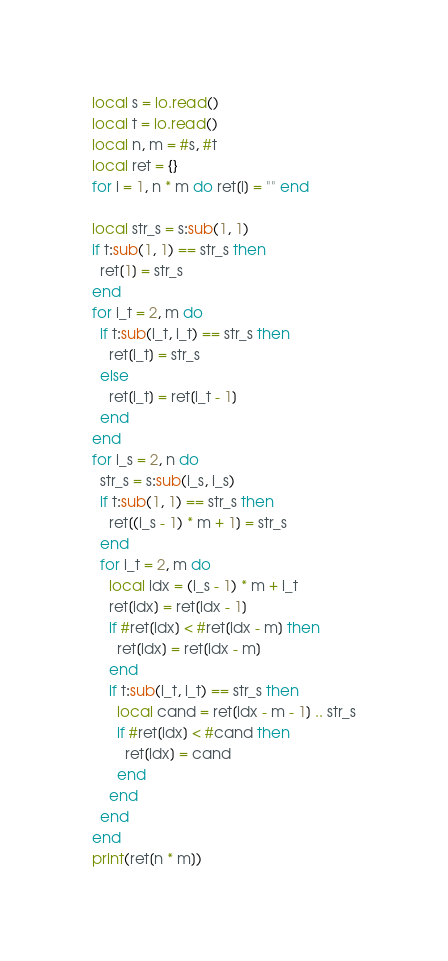Convert code to text. <code><loc_0><loc_0><loc_500><loc_500><_Lua_>local s = io.read()
local t = io.read()
local n, m = #s, #t
local ret = {}
for i = 1, n * m do ret[i] = "" end

local str_s = s:sub(1, 1)
if t:sub(1, 1) == str_s then
  ret[1] = str_s
end
for i_t = 2, m do
  if t:sub(i_t, i_t) == str_s then
    ret[i_t] = str_s
  else
    ret[i_t] = ret[i_t - 1]
  end
end
for i_s = 2, n do
  str_s = s:sub(i_s, i_s)
  if t:sub(1, 1) == str_s then
    ret[(i_s - 1) * m + 1] = str_s
  end
  for i_t = 2, m do
    local idx = (i_s - 1) * m + i_t
    ret[idx] = ret[idx - 1]
    if #ret[idx] < #ret[idx - m] then
      ret[idx] = ret[idx - m]
    end
    if t:sub(i_t, i_t) == str_s then
      local cand = ret[idx - m - 1] .. str_s
      if #ret[idx] < #cand then
        ret[idx] = cand
      end
    end
  end
end
print(ret[n * m])
</code> 